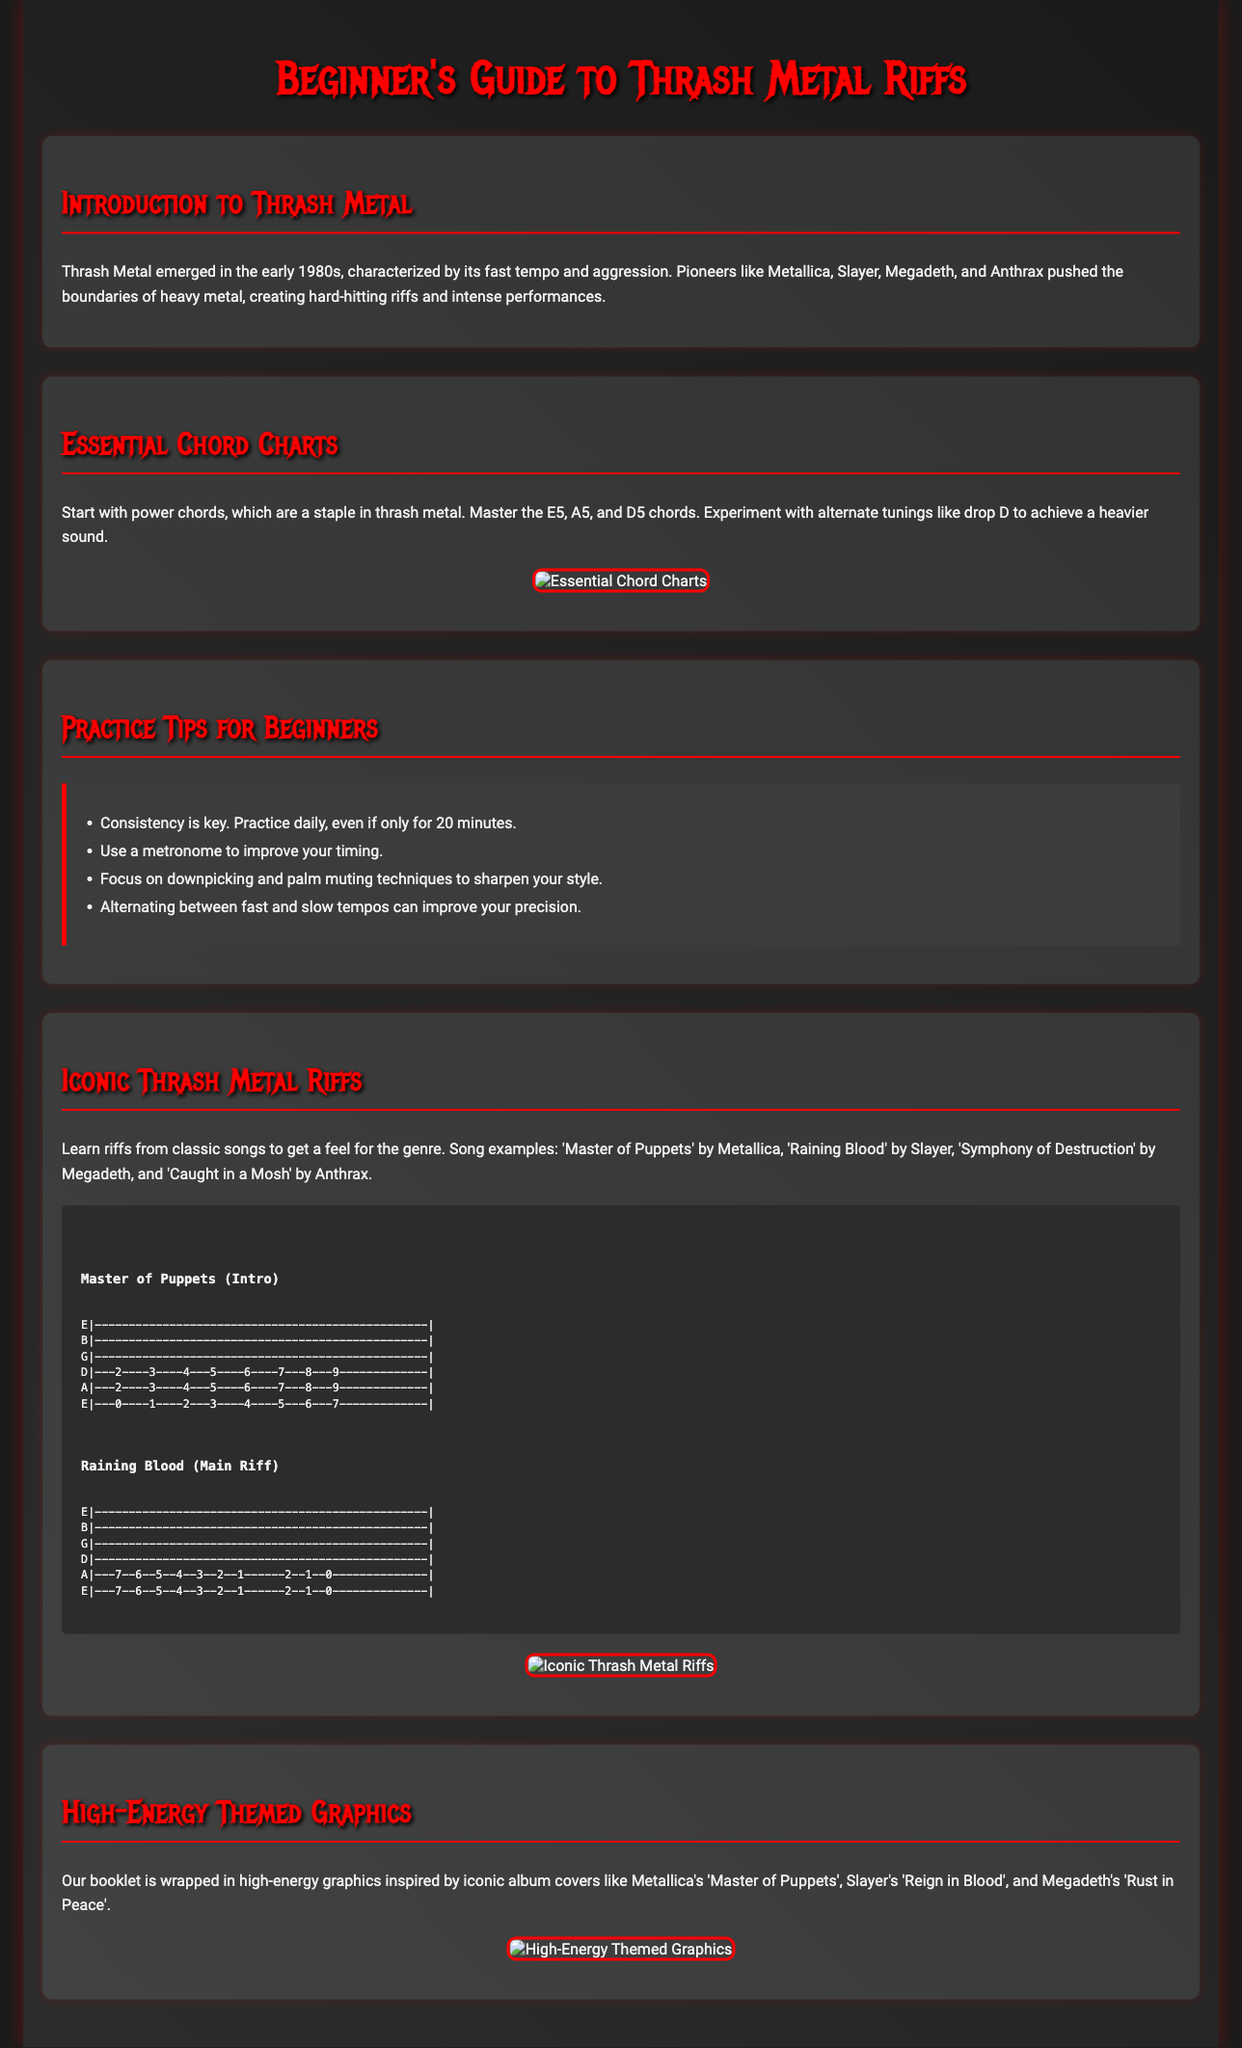What is the title of the booklet? The title of the booklet is prominently displayed at the beginning of the document.
Answer: Beginner's Guide to Thrash Metal Riffs Who are some iconic thrash metal pioneers mentioned? The document lists key bands that shaped thrash metal in the introduction.
Answer: Metallica, Slayer, Megadeth, Anthrax What is the primary chord type introduced for beginners? The essential chord charts section highlights the specific chord type emphasized for beginners.
Answer: Power chords How long should beginners practice daily according to the tips? The practice tips section provides a recommendation for daily practice duration.
Answer: 20 minutes What is a recommended technique to improve timing? The practice tips suggest a tool that can help improve timing in practice.
Answer: Metronome Which song is mentioned as an example of iconic thrash riffs? The Riffs section includes classic song examples related to thrash metal.
Answer: Master of Puppets What style of graphics does the booklet use? The document describes the visual style that surrounds the content of the booklet.
Answer: High-energy themed graphics What is the background color used for the body of the document? The background color set in the styling of the document is a significant visual element.
Answer: #1a1a1a 